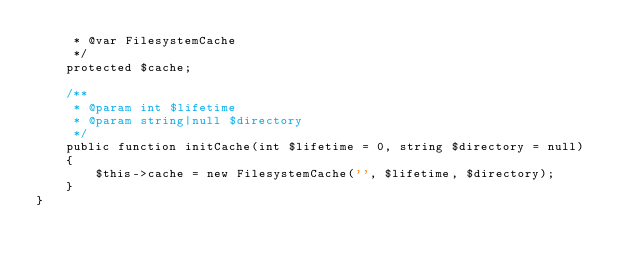Convert code to text. <code><loc_0><loc_0><loc_500><loc_500><_PHP_>     * @var FilesystemCache
     */
    protected $cache;

    /**
     * @param int $lifetime
     * @param string|null $directory
     */
    public function initCache(int $lifetime = 0, string $directory = null)
    {
        $this->cache = new FilesystemCache('', $lifetime, $directory);
    }
}</code> 